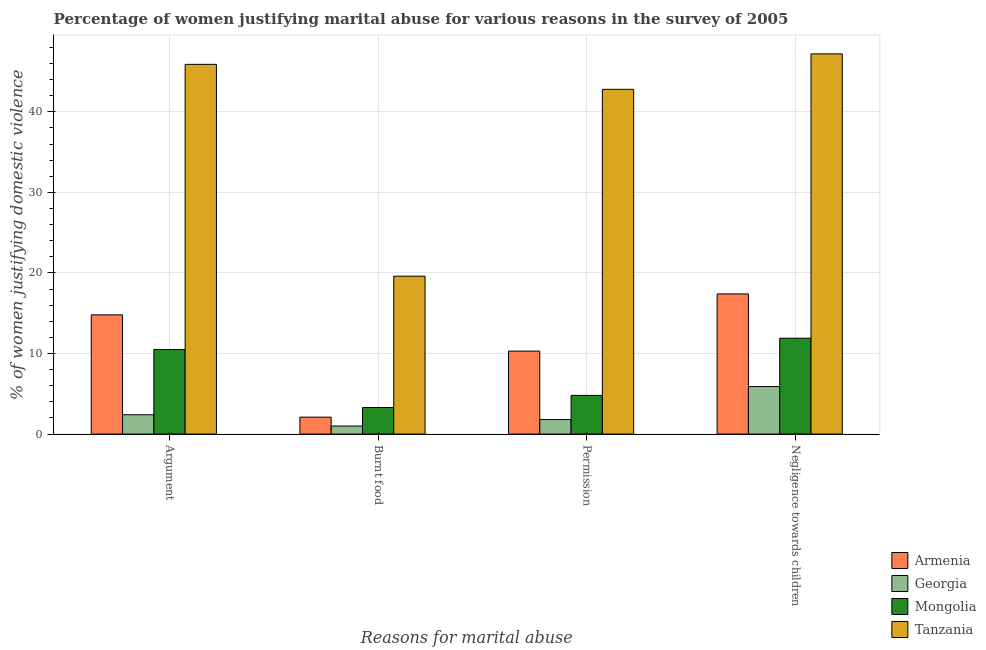How many different coloured bars are there?
Your response must be concise. 4. Are the number of bars per tick equal to the number of legend labels?
Give a very brief answer. Yes. How many bars are there on the 2nd tick from the left?
Ensure brevity in your answer.  4. What is the label of the 1st group of bars from the left?
Keep it short and to the point. Argument. Across all countries, what is the maximum percentage of women justifying abuse for burning food?
Your answer should be very brief. 19.6. In which country was the percentage of women justifying abuse for burning food maximum?
Give a very brief answer. Tanzania. In which country was the percentage of women justifying abuse in the case of an argument minimum?
Ensure brevity in your answer.  Georgia. What is the total percentage of women justifying abuse in the case of an argument in the graph?
Your response must be concise. 73.6. What is the difference between the percentage of women justifying abuse for going without permission in Mongolia and that in Armenia?
Give a very brief answer. -5.5. What is the difference between the percentage of women justifying abuse for burning food in Mongolia and the percentage of women justifying abuse in the case of an argument in Tanzania?
Your answer should be very brief. -42.6. What is the average percentage of women justifying abuse for burning food per country?
Give a very brief answer. 6.5. What is the difference between the percentage of women justifying abuse for showing negligence towards children and percentage of women justifying abuse in the case of an argument in Georgia?
Give a very brief answer. 3.5. What is the ratio of the percentage of women justifying abuse in the case of an argument in Mongolia to that in Georgia?
Keep it short and to the point. 4.38. What is the difference between the highest and the second highest percentage of women justifying abuse for burning food?
Give a very brief answer. 16.3. What is the difference between the highest and the lowest percentage of women justifying abuse for burning food?
Your answer should be very brief. 18.6. Is the sum of the percentage of women justifying abuse for going without permission in Tanzania and Armenia greater than the maximum percentage of women justifying abuse in the case of an argument across all countries?
Provide a short and direct response. Yes. What does the 4th bar from the left in Burnt food represents?
Provide a short and direct response. Tanzania. What does the 4th bar from the right in Argument represents?
Your answer should be very brief. Armenia. How many bars are there?
Make the answer very short. 16. Are all the bars in the graph horizontal?
Ensure brevity in your answer.  No. How many countries are there in the graph?
Ensure brevity in your answer.  4. What is the difference between two consecutive major ticks on the Y-axis?
Your answer should be very brief. 10. Are the values on the major ticks of Y-axis written in scientific E-notation?
Your response must be concise. No. Does the graph contain any zero values?
Give a very brief answer. No. Does the graph contain grids?
Offer a very short reply. Yes. What is the title of the graph?
Offer a very short reply. Percentage of women justifying marital abuse for various reasons in the survey of 2005. Does "High income" appear as one of the legend labels in the graph?
Ensure brevity in your answer.  No. What is the label or title of the X-axis?
Provide a succinct answer. Reasons for marital abuse. What is the label or title of the Y-axis?
Provide a short and direct response. % of women justifying domestic violence. What is the % of women justifying domestic violence in Tanzania in Argument?
Your response must be concise. 45.9. What is the % of women justifying domestic violence of Mongolia in Burnt food?
Ensure brevity in your answer.  3.3. What is the % of women justifying domestic violence in Tanzania in Burnt food?
Offer a terse response. 19.6. What is the % of women justifying domestic violence of Armenia in Permission?
Ensure brevity in your answer.  10.3. What is the % of women justifying domestic violence in Georgia in Permission?
Make the answer very short. 1.8. What is the % of women justifying domestic violence of Tanzania in Permission?
Offer a terse response. 42.8. What is the % of women justifying domestic violence in Mongolia in Negligence towards children?
Offer a terse response. 11.9. What is the % of women justifying domestic violence in Tanzania in Negligence towards children?
Your answer should be very brief. 47.2. Across all Reasons for marital abuse, what is the maximum % of women justifying domestic violence of Mongolia?
Your response must be concise. 11.9. Across all Reasons for marital abuse, what is the maximum % of women justifying domestic violence in Tanzania?
Provide a succinct answer. 47.2. Across all Reasons for marital abuse, what is the minimum % of women justifying domestic violence of Georgia?
Keep it short and to the point. 1. Across all Reasons for marital abuse, what is the minimum % of women justifying domestic violence in Mongolia?
Provide a short and direct response. 3.3. Across all Reasons for marital abuse, what is the minimum % of women justifying domestic violence of Tanzania?
Make the answer very short. 19.6. What is the total % of women justifying domestic violence in Armenia in the graph?
Provide a succinct answer. 44.6. What is the total % of women justifying domestic violence in Mongolia in the graph?
Keep it short and to the point. 30.5. What is the total % of women justifying domestic violence in Tanzania in the graph?
Provide a short and direct response. 155.5. What is the difference between the % of women justifying domestic violence in Armenia in Argument and that in Burnt food?
Make the answer very short. 12.7. What is the difference between the % of women justifying domestic violence in Georgia in Argument and that in Burnt food?
Provide a short and direct response. 1.4. What is the difference between the % of women justifying domestic violence of Tanzania in Argument and that in Burnt food?
Offer a terse response. 26.3. What is the difference between the % of women justifying domestic violence in Armenia in Argument and that in Permission?
Your answer should be compact. 4.5. What is the difference between the % of women justifying domestic violence in Georgia in Argument and that in Permission?
Make the answer very short. 0.6. What is the difference between the % of women justifying domestic violence of Mongolia in Argument and that in Permission?
Your answer should be compact. 5.7. What is the difference between the % of women justifying domestic violence of Tanzania in Argument and that in Permission?
Keep it short and to the point. 3.1. What is the difference between the % of women justifying domestic violence of Armenia in Argument and that in Negligence towards children?
Provide a succinct answer. -2.6. What is the difference between the % of women justifying domestic violence in Armenia in Burnt food and that in Permission?
Give a very brief answer. -8.2. What is the difference between the % of women justifying domestic violence in Georgia in Burnt food and that in Permission?
Provide a succinct answer. -0.8. What is the difference between the % of women justifying domestic violence in Tanzania in Burnt food and that in Permission?
Provide a short and direct response. -23.2. What is the difference between the % of women justifying domestic violence in Armenia in Burnt food and that in Negligence towards children?
Offer a terse response. -15.3. What is the difference between the % of women justifying domestic violence of Georgia in Burnt food and that in Negligence towards children?
Provide a short and direct response. -4.9. What is the difference between the % of women justifying domestic violence of Mongolia in Burnt food and that in Negligence towards children?
Give a very brief answer. -8.6. What is the difference between the % of women justifying domestic violence in Tanzania in Burnt food and that in Negligence towards children?
Keep it short and to the point. -27.6. What is the difference between the % of women justifying domestic violence in Armenia in Permission and that in Negligence towards children?
Your response must be concise. -7.1. What is the difference between the % of women justifying domestic violence of Armenia in Argument and the % of women justifying domestic violence of Georgia in Burnt food?
Keep it short and to the point. 13.8. What is the difference between the % of women justifying domestic violence of Armenia in Argument and the % of women justifying domestic violence of Mongolia in Burnt food?
Make the answer very short. 11.5. What is the difference between the % of women justifying domestic violence in Armenia in Argument and the % of women justifying domestic violence in Tanzania in Burnt food?
Keep it short and to the point. -4.8. What is the difference between the % of women justifying domestic violence of Georgia in Argument and the % of women justifying domestic violence of Mongolia in Burnt food?
Offer a very short reply. -0.9. What is the difference between the % of women justifying domestic violence in Georgia in Argument and the % of women justifying domestic violence in Tanzania in Burnt food?
Provide a short and direct response. -17.2. What is the difference between the % of women justifying domestic violence of Mongolia in Argument and the % of women justifying domestic violence of Tanzania in Burnt food?
Give a very brief answer. -9.1. What is the difference between the % of women justifying domestic violence in Armenia in Argument and the % of women justifying domestic violence in Tanzania in Permission?
Keep it short and to the point. -28. What is the difference between the % of women justifying domestic violence in Georgia in Argument and the % of women justifying domestic violence in Tanzania in Permission?
Give a very brief answer. -40.4. What is the difference between the % of women justifying domestic violence of Mongolia in Argument and the % of women justifying domestic violence of Tanzania in Permission?
Offer a very short reply. -32.3. What is the difference between the % of women justifying domestic violence in Armenia in Argument and the % of women justifying domestic violence in Georgia in Negligence towards children?
Ensure brevity in your answer.  8.9. What is the difference between the % of women justifying domestic violence in Armenia in Argument and the % of women justifying domestic violence in Tanzania in Negligence towards children?
Provide a succinct answer. -32.4. What is the difference between the % of women justifying domestic violence of Georgia in Argument and the % of women justifying domestic violence of Tanzania in Negligence towards children?
Ensure brevity in your answer.  -44.8. What is the difference between the % of women justifying domestic violence of Mongolia in Argument and the % of women justifying domestic violence of Tanzania in Negligence towards children?
Make the answer very short. -36.7. What is the difference between the % of women justifying domestic violence of Armenia in Burnt food and the % of women justifying domestic violence of Georgia in Permission?
Ensure brevity in your answer.  0.3. What is the difference between the % of women justifying domestic violence of Armenia in Burnt food and the % of women justifying domestic violence of Mongolia in Permission?
Your answer should be very brief. -2.7. What is the difference between the % of women justifying domestic violence of Armenia in Burnt food and the % of women justifying domestic violence of Tanzania in Permission?
Provide a short and direct response. -40.7. What is the difference between the % of women justifying domestic violence in Georgia in Burnt food and the % of women justifying domestic violence in Tanzania in Permission?
Keep it short and to the point. -41.8. What is the difference between the % of women justifying domestic violence in Mongolia in Burnt food and the % of women justifying domestic violence in Tanzania in Permission?
Keep it short and to the point. -39.5. What is the difference between the % of women justifying domestic violence in Armenia in Burnt food and the % of women justifying domestic violence in Tanzania in Negligence towards children?
Provide a succinct answer. -45.1. What is the difference between the % of women justifying domestic violence of Georgia in Burnt food and the % of women justifying domestic violence of Mongolia in Negligence towards children?
Your response must be concise. -10.9. What is the difference between the % of women justifying domestic violence in Georgia in Burnt food and the % of women justifying domestic violence in Tanzania in Negligence towards children?
Your response must be concise. -46.2. What is the difference between the % of women justifying domestic violence in Mongolia in Burnt food and the % of women justifying domestic violence in Tanzania in Negligence towards children?
Provide a short and direct response. -43.9. What is the difference between the % of women justifying domestic violence in Armenia in Permission and the % of women justifying domestic violence in Tanzania in Negligence towards children?
Offer a terse response. -36.9. What is the difference between the % of women justifying domestic violence in Georgia in Permission and the % of women justifying domestic violence in Tanzania in Negligence towards children?
Ensure brevity in your answer.  -45.4. What is the difference between the % of women justifying domestic violence of Mongolia in Permission and the % of women justifying domestic violence of Tanzania in Negligence towards children?
Keep it short and to the point. -42.4. What is the average % of women justifying domestic violence of Armenia per Reasons for marital abuse?
Give a very brief answer. 11.15. What is the average % of women justifying domestic violence of Georgia per Reasons for marital abuse?
Your response must be concise. 2.77. What is the average % of women justifying domestic violence of Mongolia per Reasons for marital abuse?
Offer a very short reply. 7.62. What is the average % of women justifying domestic violence in Tanzania per Reasons for marital abuse?
Your response must be concise. 38.88. What is the difference between the % of women justifying domestic violence in Armenia and % of women justifying domestic violence in Tanzania in Argument?
Your answer should be very brief. -31.1. What is the difference between the % of women justifying domestic violence in Georgia and % of women justifying domestic violence in Mongolia in Argument?
Give a very brief answer. -8.1. What is the difference between the % of women justifying domestic violence in Georgia and % of women justifying domestic violence in Tanzania in Argument?
Your answer should be compact. -43.5. What is the difference between the % of women justifying domestic violence of Mongolia and % of women justifying domestic violence of Tanzania in Argument?
Provide a short and direct response. -35.4. What is the difference between the % of women justifying domestic violence of Armenia and % of women justifying domestic violence of Mongolia in Burnt food?
Ensure brevity in your answer.  -1.2. What is the difference between the % of women justifying domestic violence in Armenia and % of women justifying domestic violence in Tanzania in Burnt food?
Keep it short and to the point. -17.5. What is the difference between the % of women justifying domestic violence in Georgia and % of women justifying domestic violence in Tanzania in Burnt food?
Your answer should be compact. -18.6. What is the difference between the % of women justifying domestic violence in Mongolia and % of women justifying domestic violence in Tanzania in Burnt food?
Your answer should be very brief. -16.3. What is the difference between the % of women justifying domestic violence in Armenia and % of women justifying domestic violence in Mongolia in Permission?
Keep it short and to the point. 5.5. What is the difference between the % of women justifying domestic violence of Armenia and % of women justifying domestic violence of Tanzania in Permission?
Your response must be concise. -32.5. What is the difference between the % of women justifying domestic violence of Georgia and % of women justifying domestic violence of Mongolia in Permission?
Your answer should be compact. -3. What is the difference between the % of women justifying domestic violence of Georgia and % of women justifying domestic violence of Tanzania in Permission?
Your response must be concise. -41. What is the difference between the % of women justifying domestic violence in Mongolia and % of women justifying domestic violence in Tanzania in Permission?
Offer a very short reply. -38. What is the difference between the % of women justifying domestic violence of Armenia and % of women justifying domestic violence of Georgia in Negligence towards children?
Your response must be concise. 11.5. What is the difference between the % of women justifying domestic violence in Armenia and % of women justifying domestic violence in Tanzania in Negligence towards children?
Your answer should be very brief. -29.8. What is the difference between the % of women justifying domestic violence of Georgia and % of women justifying domestic violence of Mongolia in Negligence towards children?
Ensure brevity in your answer.  -6. What is the difference between the % of women justifying domestic violence in Georgia and % of women justifying domestic violence in Tanzania in Negligence towards children?
Give a very brief answer. -41.3. What is the difference between the % of women justifying domestic violence of Mongolia and % of women justifying domestic violence of Tanzania in Negligence towards children?
Your answer should be compact. -35.3. What is the ratio of the % of women justifying domestic violence of Armenia in Argument to that in Burnt food?
Provide a short and direct response. 7.05. What is the ratio of the % of women justifying domestic violence of Georgia in Argument to that in Burnt food?
Keep it short and to the point. 2.4. What is the ratio of the % of women justifying domestic violence in Mongolia in Argument to that in Burnt food?
Offer a very short reply. 3.18. What is the ratio of the % of women justifying domestic violence in Tanzania in Argument to that in Burnt food?
Offer a very short reply. 2.34. What is the ratio of the % of women justifying domestic violence of Armenia in Argument to that in Permission?
Ensure brevity in your answer.  1.44. What is the ratio of the % of women justifying domestic violence of Georgia in Argument to that in Permission?
Offer a terse response. 1.33. What is the ratio of the % of women justifying domestic violence of Mongolia in Argument to that in Permission?
Your answer should be very brief. 2.19. What is the ratio of the % of women justifying domestic violence of Tanzania in Argument to that in Permission?
Your response must be concise. 1.07. What is the ratio of the % of women justifying domestic violence in Armenia in Argument to that in Negligence towards children?
Give a very brief answer. 0.85. What is the ratio of the % of women justifying domestic violence in Georgia in Argument to that in Negligence towards children?
Offer a terse response. 0.41. What is the ratio of the % of women justifying domestic violence of Mongolia in Argument to that in Negligence towards children?
Provide a succinct answer. 0.88. What is the ratio of the % of women justifying domestic violence of Tanzania in Argument to that in Negligence towards children?
Your response must be concise. 0.97. What is the ratio of the % of women justifying domestic violence of Armenia in Burnt food to that in Permission?
Keep it short and to the point. 0.2. What is the ratio of the % of women justifying domestic violence in Georgia in Burnt food to that in Permission?
Offer a very short reply. 0.56. What is the ratio of the % of women justifying domestic violence of Mongolia in Burnt food to that in Permission?
Your answer should be compact. 0.69. What is the ratio of the % of women justifying domestic violence in Tanzania in Burnt food to that in Permission?
Offer a terse response. 0.46. What is the ratio of the % of women justifying domestic violence in Armenia in Burnt food to that in Negligence towards children?
Provide a succinct answer. 0.12. What is the ratio of the % of women justifying domestic violence in Georgia in Burnt food to that in Negligence towards children?
Make the answer very short. 0.17. What is the ratio of the % of women justifying domestic violence of Mongolia in Burnt food to that in Negligence towards children?
Provide a short and direct response. 0.28. What is the ratio of the % of women justifying domestic violence of Tanzania in Burnt food to that in Negligence towards children?
Your answer should be very brief. 0.42. What is the ratio of the % of women justifying domestic violence in Armenia in Permission to that in Negligence towards children?
Give a very brief answer. 0.59. What is the ratio of the % of women justifying domestic violence of Georgia in Permission to that in Negligence towards children?
Your response must be concise. 0.31. What is the ratio of the % of women justifying domestic violence in Mongolia in Permission to that in Negligence towards children?
Your response must be concise. 0.4. What is the ratio of the % of women justifying domestic violence in Tanzania in Permission to that in Negligence towards children?
Offer a terse response. 0.91. What is the difference between the highest and the second highest % of women justifying domestic violence in Georgia?
Provide a succinct answer. 3.5. What is the difference between the highest and the lowest % of women justifying domestic violence in Mongolia?
Offer a very short reply. 8.6. What is the difference between the highest and the lowest % of women justifying domestic violence in Tanzania?
Your answer should be very brief. 27.6. 